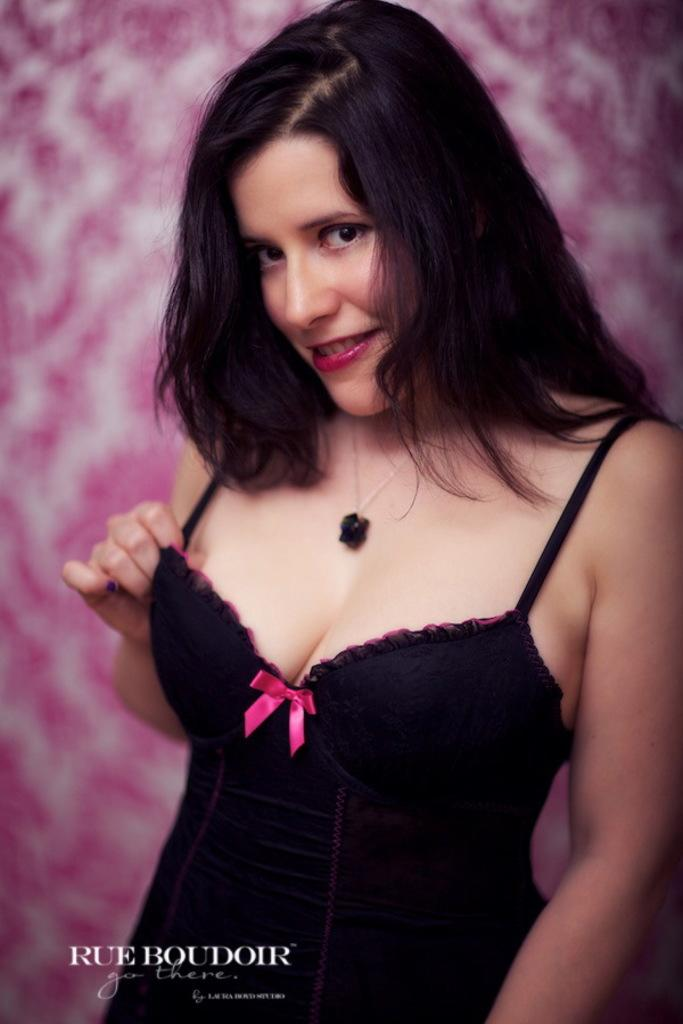Who is present in the image? There is a woman in the image. What is the woman doing in the image? The woman is standing and smiling. Can you describe the background of the image? The background of the image is blurry. Is there any text in the image? Yes, there is text written at the bottom of the image. What type of goose can be seen using a hammer in the image? There is no goose or hammer present in the image. How does the earthquake affect the woman in the image? There is no earthquake present in the image, so its effects cannot be observed. 